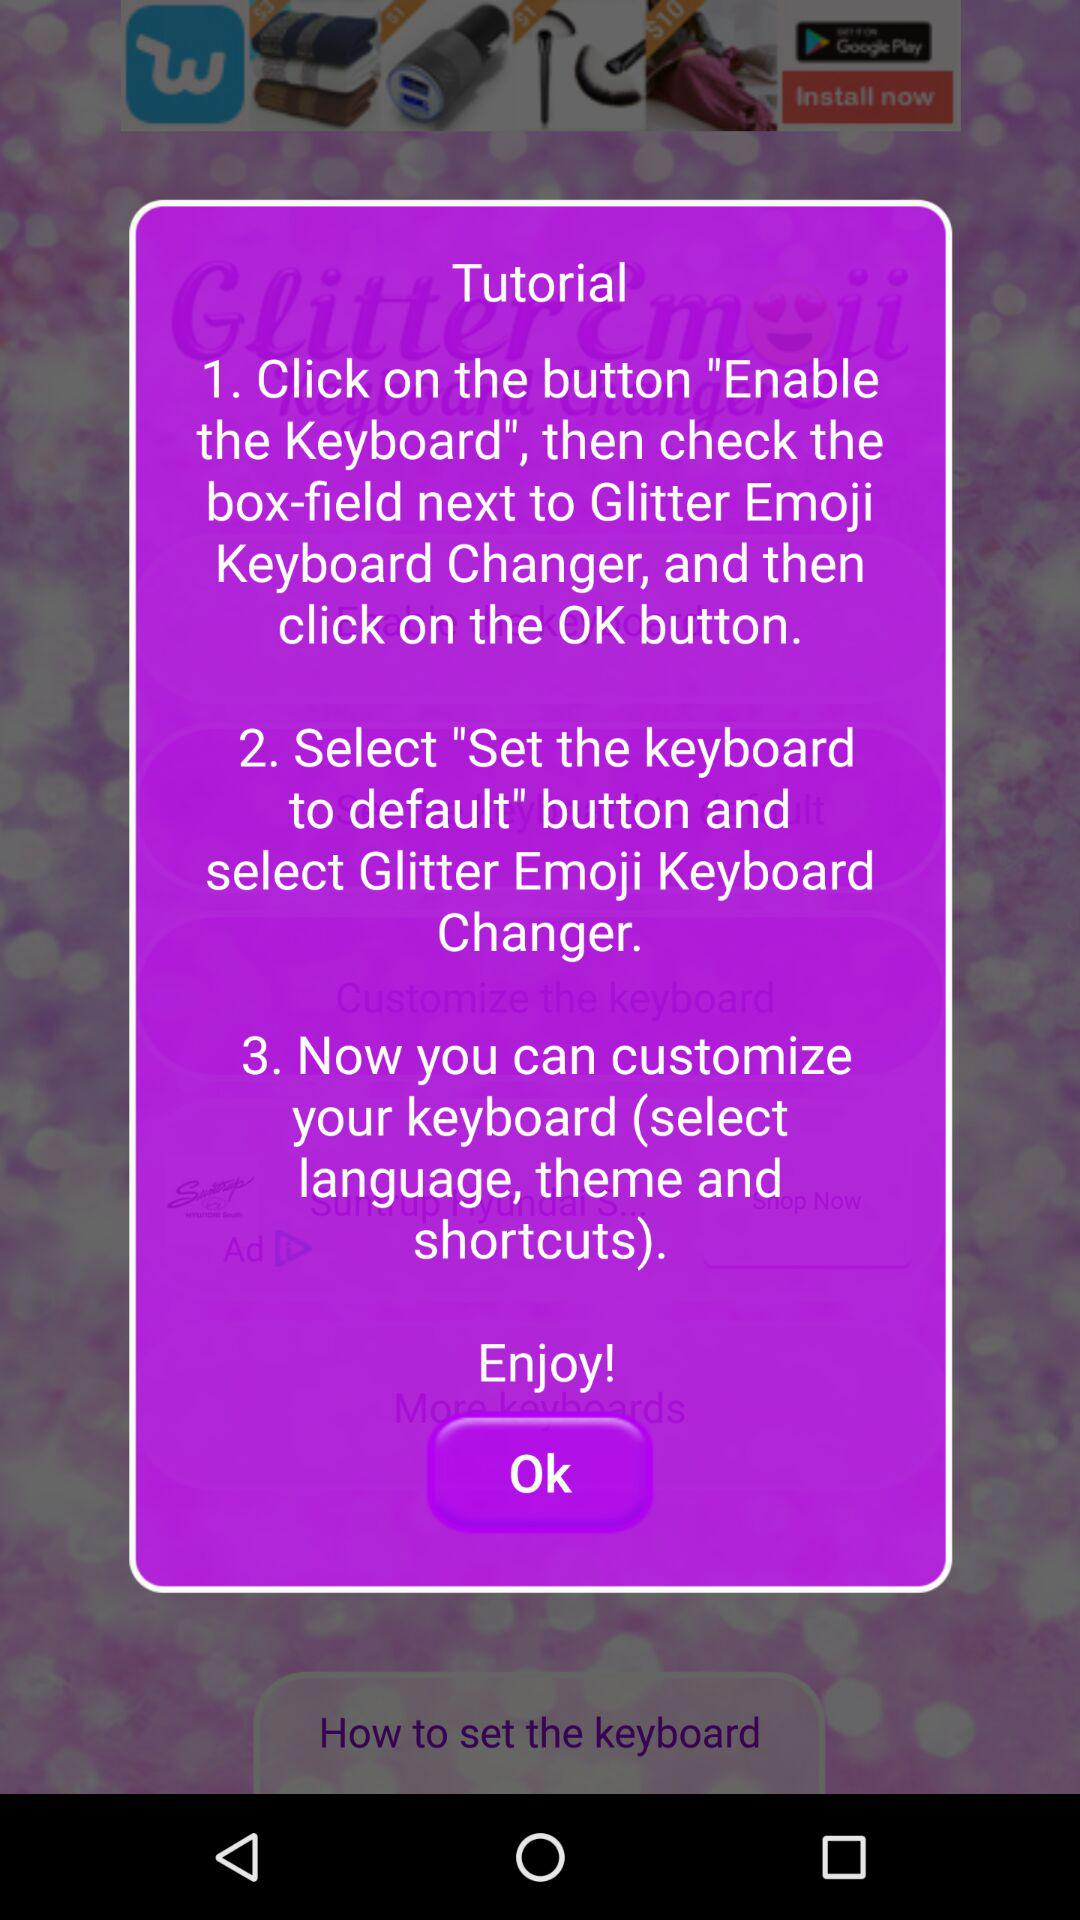What is the name of the application?
When the provided information is insufficient, respond with <no answer>. <no answer> 